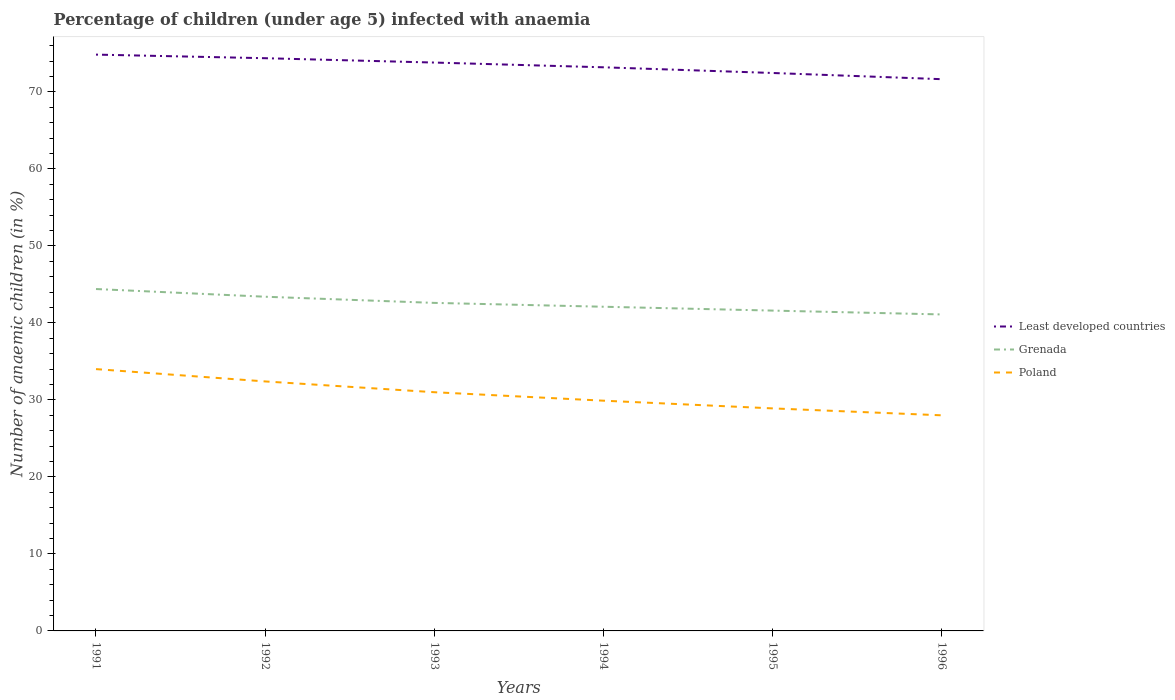Does the line corresponding to Grenada intersect with the line corresponding to Least developed countries?
Keep it short and to the point. No. Is the number of lines equal to the number of legend labels?
Provide a short and direct response. Yes. Across all years, what is the maximum percentage of children infected with anaemia in in Grenada?
Give a very brief answer. 41.1. What is the total percentage of children infected with anaemia in in Grenada in the graph?
Make the answer very short. 1. What is the difference between the highest and the second highest percentage of children infected with anaemia in in Least developed countries?
Provide a succinct answer. 3.19. How many years are there in the graph?
Provide a succinct answer. 6. What is the difference between two consecutive major ticks on the Y-axis?
Give a very brief answer. 10. Are the values on the major ticks of Y-axis written in scientific E-notation?
Give a very brief answer. No. Does the graph contain any zero values?
Offer a terse response. No. How many legend labels are there?
Your answer should be very brief. 3. How are the legend labels stacked?
Your answer should be very brief. Vertical. What is the title of the graph?
Provide a succinct answer. Percentage of children (under age 5) infected with anaemia. What is the label or title of the X-axis?
Your response must be concise. Years. What is the label or title of the Y-axis?
Provide a succinct answer. Number of anaemic children (in %). What is the Number of anaemic children (in %) of Least developed countries in 1991?
Provide a short and direct response. 74.84. What is the Number of anaemic children (in %) of Grenada in 1991?
Make the answer very short. 44.4. What is the Number of anaemic children (in %) in Poland in 1991?
Give a very brief answer. 34. What is the Number of anaemic children (in %) in Least developed countries in 1992?
Your answer should be very brief. 74.38. What is the Number of anaemic children (in %) in Grenada in 1992?
Give a very brief answer. 43.4. What is the Number of anaemic children (in %) of Poland in 1992?
Provide a short and direct response. 32.4. What is the Number of anaemic children (in %) in Least developed countries in 1993?
Your response must be concise. 73.81. What is the Number of anaemic children (in %) in Grenada in 1993?
Your answer should be very brief. 42.6. What is the Number of anaemic children (in %) in Poland in 1993?
Offer a terse response. 31. What is the Number of anaemic children (in %) in Least developed countries in 1994?
Offer a very short reply. 73.2. What is the Number of anaemic children (in %) in Grenada in 1994?
Offer a very short reply. 42.1. What is the Number of anaemic children (in %) of Poland in 1994?
Make the answer very short. 29.9. What is the Number of anaemic children (in %) of Least developed countries in 1995?
Offer a terse response. 72.46. What is the Number of anaemic children (in %) of Grenada in 1995?
Provide a short and direct response. 41.6. What is the Number of anaemic children (in %) in Poland in 1995?
Your response must be concise. 28.9. What is the Number of anaemic children (in %) of Least developed countries in 1996?
Offer a terse response. 71.65. What is the Number of anaemic children (in %) of Grenada in 1996?
Your answer should be very brief. 41.1. What is the Number of anaemic children (in %) in Poland in 1996?
Ensure brevity in your answer.  28. Across all years, what is the maximum Number of anaemic children (in %) of Least developed countries?
Offer a terse response. 74.84. Across all years, what is the maximum Number of anaemic children (in %) in Grenada?
Your answer should be compact. 44.4. Across all years, what is the maximum Number of anaemic children (in %) in Poland?
Provide a succinct answer. 34. Across all years, what is the minimum Number of anaemic children (in %) in Least developed countries?
Your response must be concise. 71.65. Across all years, what is the minimum Number of anaemic children (in %) of Grenada?
Your response must be concise. 41.1. What is the total Number of anaemic children (in %) in Least developed countries in the graph?
Provide a succinct answer. 440.33. What is the total Number of anaemic children (in %) in Grenada in the graph?
Keep it short and to the point. 255.2. What is the total Number of anaemic children (in %) of Poland in the graph?
Your response must be concise. 184.2. What is the difference between the Number of anaemic children (in %) of Least developed countries in 1991 and that in 1992?
Your response must be concise. 0.47. What is the difference between the Number of anaemic children (in %) in Poland in 1991 and that in 1992?
Provide a succinct answer. 1.6. What is the difference between the Number of anaemic children (in %) in Least developed countries in 1991 and that in 1993?
Your answer should be compact. 1.03. What is the difference between the Number of anaemic children (in %) in Grenada in 1991 and that in 1993?
Provide a short and direct response. 1.8. What is the difference between the Number of anaemic children (in %) in Poland in 1991 and that in 1993?
Provide a succinct answer. 3. What is the difference between the Number of anaemic children (in %) of Least developed countries in 1991 and that in 1994?
Make the answer very short. 1.65. What is the difference between the Number of anaemic children (in %) in Grenada in 1991 and that in 1994?
Offer a very short reply. 2.3. What is the difference between the Number of anaemic children (in %) in Poland in 1991 and that in 1994?
Give a very brief answer. 4.1. What is the difference between the Number of anaemic children (in %) of Least developed countries in 1991 and that in 1995?
Provide a short and direct response. 2.39. What is the difference between the Number of anaemic children (in %) of Grenada in 1991 and that in 1995?
Your response must be concise. 2.8. What is the difference between the Number of anaemic children (in %) in Least developed countries in 1991 and that in 1996?
Provide a succinct answer. 3.19. What is the difference between the Number of anaemic children (in %) of Grenada in 1991 and that in 1996?
Your answer should be very brief. 3.3. What is the difference between the Number of anaemic children (in %) of Least developed countries in 1992 and that in 1993?
Offer a very short reply. 0.56. What is the difference between the Number of anaemic children (in %) in Grenada in 1992 and that in 1993?
Offer a very short reply. 0.8. What is the difference between the Number of anaemic children (in %) in Least developed countries in 1992 and that in 1994?
Give a very brief answer. 1.18. What is the difference between the Number of anaemic children (in %) of Poland in 1992 and that in 1994?
Offer a terse response. 2.5. What is the difference between the Number of anaemic children (in %) in Least developed countries in 1992 and that in 1995?
Provide a short and direct response. 1.92. What is the difference between the Number of anaemic children (in %) of Grenada in 1992 and that in 1995?
Ensure brevity in your answer.  1.8. What is the difference between the Number of anaemic children (in %) in Least developed countries in 1992 and that in 1996?
Your answer should be very brief. 2.72. What is the difference between the Number of anaemic children (in %) of Least developed countries in 1993 and that in 1994?
Provide a succinct answer. 0.62. What is the difference between the Number of anaemic children (in %) in Poland in 1993 and that in 1994?
Provide a succinct answer. 1.1. What is the difference between the Number of anaemic children (in %) in Least developed countries in 1993 and that in 1995?
Make the answer very short. 1.35. What is the difference between the Number of anaemic children (in %) in Least developed countries in 1993 and that in 1996?
Your answer should be compact. 2.16. What is the difference between the Number of anaemic children (in %) in Poland in 1993 and that in 1996?
Your answer should be very brief. 3. What is the difference between the Number of anaemic children (in %) of Least developed countries in 1994 and that in 1995?
Ensure brevity in your answer.  0.74. What is the difference between the Number of anaemic children (in %) in Poland in 1994 and that in 1995?
Give a very brief answer. 1. What is the difference between the Number of anaemic children (in %) in Least developed countries in 1994 and that in 1996?
Give a very brief answer. 1.54. What is the difference between the Number of anaemic children (in %) of Grenada in 1994 and that in 1996?
Your response must be concise. 1. What is the difference between the Number of anaemic children (in %) of Poland in 1994 and that in 1996?
Provide a succinct answer. 1.9. What is the difference between the Number of anaemic children (in %) in Least developed countries in 1995 and that in 1996?
Your answer should be very brief. 0.81. What is the difference between the Number of anaemic children (in %) in Grenada in 1995 and that in 1996?
Provide a succinct answer. 0.5. What is the difference between the Number of anaemic children (in %) of Least developed countries in 1991 and the Number of anaemic children (in %) of Grenada in 1992?
Offer a terse response. 31.44. What is the difference between the Number of anaemic children (in %) in Least developed countries in 1991 and the Number of anaemic children (in %) in Poland in 1992?
Ensure brevity in your answer.  42.44. What is the difference between the Number of anaemic children (in %) in Least developed countries in 1991 and the Number of anaemic children (in %) in Grenada in 1993?
Offer a very short reply. 32.24. What is the difference between the Number of anaemic children (in %) of Least developed countries in 1991 and the Number of anaemic children (in %) of Poland in 1993?
Your answer should be compact. 43.84. What is the difference between the Number of anaemic children (in %) of Least developed countries in 1991 and the Number of anaemic children (in %) of Grenada in 1994?
Give a very brief answer. 32.74. What is the difference between the Number of anaemic children (in %) in Least developed countries in 1991 and the Number of anaemic children (in %) in Poland in 1994?
Make the answer very short. 44.94. What is the difference between the Number of anaemic children (in %) of Least developed countries in 1991 and the Number of anaemic children (in %) of Grenada in 1995?
Your response must be concise. 33.24. What is the difference between the Number of anaemic children (in %) of Least developed countries in 1991 and the Number of anaemic children (in %) of Poland in 1995?
Ensure brevity in your answer.  45.94. What is the difference between the Number of anaemic children (in %) of Least developed countries in 1991 and the Number of anaemic children (in %) of Grenada in 1996?
Keep it short and to the point. 33.74. What is the difference between the Number of anaemic children (in %) in Least developed countries in 1991 and the Number of anaemic children (in %) in Poland in 1996?
Your answer should be compact. 46.84. What is the difference between the Number of anaemic children (in %) of Least developed countries in 1992 and the Number of anaemic children (in %) of Grenada in 1993?
Give a very brief answer. 31.78. What is the difference between the Number of anaemic children (in %) in Least developed countries in 1992 and the Number of anaemic children (in %) in Poland in 1993?
Keep it short and to the point. 43.38. What is the difference between the Number of anaemic children (in %) of Least developed countries in 1992 and the Number of anaemic children (in %) of Grenada in 1994?
Provide a short and direct response. 32.28. What is the difference between the Number of anaemic children (in %) in Least developed countries in 1992 and the Number of anaemic children (in %) in Poland in 1994?
Ensure brevity in your answer.  44.48. What is the difference between the Number of anaemic children (in %) of Least developed countries in 1992 and the Number of anaemic children (in %) of Grenada in 1995?
Your response must be concise. 32.78. What is the difference between the Number of anaemic children (in %) of Least developed countries in 1992 and the Number of anaemic children (in %) of Poland in 1995?
Your response must be concise. 45.48. What is the difference between the Number of anaemic children (in %) of Grenada in 1992 and the Number of anaemic children (in %) of Poland in 1995?
Your response must be concise. 14.5. What is the difference between the Number of anaemic children (in %) of Least developed countries in 1992 and the Number of anaemic children (in %) of Grenada in 1996?
Provide a short and direct response. 33.28. What is the difference between the Number of anaemic children (in %) in Least developed countries in 1992 and the Number of anaemic children (in %) in Poland in 1996?
Your answer should be very brief. 46.38. What is the difference between the Number of anaemic children (in %) of Grenada in 1992 and the Number of anaemic children (in %) of Poland in 1996?
Make the answer very short. 15.4. What is the difference between the Number of anaemic children (in %) of Least developed countries in 1993 and the Number of anaemic children (in %) of Grenada in 1994?
Give a very brief answer. 31.71. What is the difference between the Number of anaemic children (in %) of Least developed countries in 1993 and the Number of anaemic children (in %) of Poland in 1994?
Make the answer very short. 43.91. What is the difference between the Number of anaemic children (in %) of Grenada in 1993 and the Number of anaemic children (in %) of Poland in 1994?
Provide a short and direct response. 12.7. What is the difference between the Number of anaemic children (in %) of Least developed countries in 1993 and the Number of anaemic children (in %) of Grenada in 1995?
Your answer should be very brief. 32.21. What is the difference between the Number of anaemic children (in %) in Least developed countries in 1993 and the Number of anaemic children (in %) in Poland in 1995?
Provide a succinct answer. 44.91. What is the difference between the Number of anaemic children (in %) in Least developed countries in 1993 and the Number of anaemic children (in %) in Grenada in 1996?
Offer a terse response. 32.71. What is the difference between the Number of anaemic children (in %) in Least developed countries in 1993 and the Number of anaemic children (in %) in Poland in 1996?
Your response must be concise. 45.81. What is the difference between the Number of anaemic children (in %) in Least developed countries in 1994 and the Number of anaemic children (in %) in Grenada in 1995?
Your response must be concise. 31.6. What is the difference between the Number of anaemic children (in %) of Least developed countries in 1994 and the Number of anaemic children (in %) of Poland in 1995?
Provide a short and direct response. 44.3. What is the difference between the Number of anaemic children (in %) of Least developed countries in 1994 and the Number of anaemic children (in %) of Grenada in 1996?
Your response must be concise. 32.1. What is the difference between the Number of anaemic children (in %) in Least developed countries in 1994 and the Number of anaemic children (in %) in Poland in 1996?
Give a very brief answer. 45.2. What is the difference between the Number of anaemic children (in %) of Least developed countries in 1995 and the Number of anaemic children (in %) of Grenada in 1996?
Your answer should be very brief. 31.36. What is the difference between the Number of anaemic children (in %) in Least developed countries in 1995 and the Number of anaemic children (in %) in Poland in 1996?
Provide a short and direct response. 44.46. What is the average Number of anaemic children (in %) of Least developed countries per year?
Provide a succinct answer. 73.39. What is the average Number of anaemic children (in %) in Grenada per year?
Ensure brevity in your answer.  42.53. What is the average Number of anaemic children (in %) of Poland per year?
Your answer should be very brief. 30.7. In the year 1991, what is the difference between the Number of anaemic children (in %) in Least developed countries and Number of anaemic children (in %) in Grenada?
Your answer should be compact. 30.44. In the year 1991, what is the difference between the Number of anaemic children (in %) of Least developed countries and Number of anaemic children (in %) of Poland?
Offer a terse response. 40.84. In the year 1991, what is the difference between the Number of anaemic children (in %) of Grenada and Number of anaemic children (in %) of Poland?
Ensure brevity in your answer.  10.4. In the year 1992, what is the difference between the Number of anaemic children (in %) in Least developed countries and Number of anaemic children (in %) in Grenada?
Provide a succinct answer. 30.98. In the year 1992, what is the difference between the Number of anaemic children (in %) in Least developed countries and Number of anaemic children (in %) in Poland?
Give a very brief answer. 41.98. In the year 1992, what is the difference between the Number of anaemic children (in %) of Grenada and Number of anaemic children (in %) of Poland?
Offer a very short reply. 11. In the year 1993, what is the difference between the Number of anaemic children (in %) in Least developed countries and Number of anaemic children (in %) in Grenada?
Ensure brevity in your answer.  31.21. In the year 1993, what is the difference between the Number of anaemic children (in %) of Least developed countries and Number of anaemic children (in %) of Poland?
Ensure brevity in your answer.  42.81. In the year 1993, what is the difference between the Number of anaemic children (in %) of Grenada and Number of anaemic children (in %) of Poland?
Make the answer very short. 11.6. In the year 1994, what is the difference between the Number of anaemic children (in %) of Least developed countries and Number of anaemic children (in %) of Grenada?
Your answer should be compact. 31.1. In the year 1994, what is the difference between the Number of anaemic children (in %) of Least developed countries and Number of anaemic children (in %) of Poland?
Keep it short and to the point. 43.3. In the year 1995, what is the difference between the Number of anaemic children (in %) of Least developed countries and Number of anaemic children (in %) of Grenada?
Your answer should be very brief. 30.86. In the year 1995, what is the difference between the Number of anaemic children (in %) in Least developed countries and Number of anaemic children (in %) in Poland?
Provide a short and direct response. 43.56. In the year 1996, what is the difference between the Number of anaemic children (in %) of Least developed countries and Number of anaemic children (in %) of Grenada?
Ensure brevity in your answer.  30.55. In the year 1996, what is the difference between the Number of anaemic children (in %) of Least developed countries and Number of anaemic children (in %) of Poland?
Your answer should be very brief. 43.65. In the year 1996, what is the difference between the Number of anaemic children (in %) in Grenada and Number of anaemic children (in %) in Poland?
Your answer should be very brief. 13.1. What is the ratio of the Number of anaemic children (in %) of Poland in 1991 to that in 1992?
Offer a very short reply. 1.05. What is the ratio of the Number of anaemic children (in %) of Grenada in 1991 to that in 1993?
Give a very brief answer. 1.04. What is the ratio of the Number of anaemic children (in %) in Poland in 1991 to that in 1993?
Your response must be concise. 1.1. What is the ratio of the Number of anaemic children (in %) of Least developed countries in 1991 to that in 1994?
Give a very brief answer. 1.02. What is the ratio of the Number of anaemic children (in %) of Grenada in 1991 to that in 1994?
Your answer should be very brief. 1.05. What is the ratio of the Number of anaemic children (in %) in Poland in 1991 to that in 1994?
Your response must be concise. 1.14. What is the ratio of the Number of anaemic children (in %) of Least developed countries in 1991 to that in 1995?
Keep it short and to the point. 1.03. What is the ratio of the Number of anaemic children (in %) in Grenada in 1991 to that in 1995?
Your answer should be compact. 1.07. What is the ratio of the Number of anaemic children (in %) in Poland in 1991 to that in 1995?
Your answer should be very brief. 1.18. What is the ratio of the Number of anaemic children (in %) in Least developed countries in 1991 to that in 1996?
Make the answer very short. 1.04. What is the ratio of the Number of anaemic children (in %) of Grenada in 1991 to that in 1996?
Provide a short and direct response. 1.08. What is the ratio of the Number of anaemic children (in %) in Poland in 1991 to that in 1996?
Your answer should be compact. 1.21. What is the ratio of the Number of anaemic children (in %) of Least developed countries in 1992 to that in 1993?
Ensure brevity in your answer.  1.01. What is the ratio of the Number of anaemic children (in %) in Grenada in 1992 to that in 1993?
Offer a terse response. 1.02. What is the ratio of the Number of anaemic children (in %) in Poland in 1992 to that in 1993?
Your answer should be compact. 1.05. What is the ratio of the Number of anaemic children (in %) of Least developed countries in 1992 to that in 1994?
Provide a short and direct response. 1.02. What is the ratio of the Number of anaemic children (in %) of Grenada in 1992 to that in 1994?
Your answer should be compact. 1.03. What is the ratio of the Number of anaemic children (in %) in Poland in 1992 to that in 1994?
Provide a succinct answer. 1.08. What is the ratio of the Number of anaemic children (in %) of Least developed countries in 1992 to that in 1995?
Offer a terse response. 1.03. What is the ratio of the Number of anaemic children (in %) in Grenada in 1992 to that in 1995?
Keep it short and to the point. 1.04. What is the ratio of the Number of anaemic children (in %) of Poland in 1992 to that in 1995?
Your answer should be very brief. 1.12. What is the ratio of the Number of anaemic children (in %) in Least developed countries in 1992 to that in 1996?
Your answer should be very brief. 1.04. What is the ratio of the Number of anaemic children (in %) of Grenada in 1992 to that in 1996?
Your answer should be very brief. 1.06. What is the ratio of the Number of anaemic children (in %) of Poland in 1992 to that in 1996?
Make the answer very short. 1.16. What is the ratio of the Number of anaemic children (in %) of Least developed countries in 1993 to that in 1994?
Provide a short and direct response. 1.01. What is the ratio of the Number of anaemic children (in %) of Grenada in 1993 to that in 1994?
Offer a terse response. 1.01. What is the ratio of the Number of anaemic children (in %) in Poland in 1993 to that in 1994?
Provide a short and direct response. 1.04. What is the ratio of the Number of anaemic children (in %) of Least developed countries in 1993 to that in 1995?
Provide a short and direct response. 1.02. What is the ratio of the Number of anaemic children (in %) of Poland in 1993 to that in 1995?
Give a very brief answer. 1.07. What is the ratio of the Number of anaemic children (in %) in Least developed countries in 1993 to that in 1996?
Your answer should be compact. 1.03. What is the ratio of the Number of anaemic children (in %) in Grenada in 1993 to that in 1996?
Keep it short and to the point. 1.04. What is the ratio of the Number of anaemic children (in %) in Poland in 1993 to that in 1996?
Your answer should be compact. 1.11. What is the ratio of the Number of anaemic children (in %) in Least developed countries in 1994 to that in 1995?
Provide a succinct answer. 1.01. What is the ratio of the Number of anaemic children (in %) in Grenada in 1994 to that in 1995?
Ensure brevity in your answer.  1.01. What is the ratio of the Number of anaemic children (in %) in Poland in 1994 to that in 1995?
Your answer should be compact. 1.03. What is the ratio of the Number of anaemic children (in %) of Least developed countries in 1994 to that in 1996?
Offer a very short reply. 1.02. What is the ratio of the Number of anaemic children (in %) of Grenada in 1994 to that in 1996?
Keep it short and to the point. 1.02. What is the ratio of the Number of anaemic children (in %) of Poland in 1994 to that in 1996?
Provide a succinct answer. 1.07. What is the ratio of the Number of anaemic children (in %) in Least developed countries in 1995 to that in 1996?
Give a very brief answer. 1.01. What is the ratio of the Number of anaemic children (in %) in Grenada in 1995 to that in 1996?
Keep it short and to the point. 1.01. What is the ratio of the Number of anaemic children (in %) of Poland in 1995 to that in 1996?
Your answer should be compact. 1.03. What is the difference between the highest and the second highest Number of anaemic children (in %) in Least developed countries?
Your answer should be very brief. 0.47. What is the difference between the highest and the second highest Number of anaemic children (in %) of Grenada?
Make the answer very short. 1. What is the difference between the highest and the second highest Number of anaemic children (in %) in Poland?
Ensure brevity in your answer.  1.6. What is the difference between the highest and the lowest Number of anaemic children (in %) in Least developed countries?
Offer a very short reply. 3.19. What is the difference between the highest and the lowest Number of anaemic children (in %) in Grenada?
Give a very brief answer. 3.3. What is the difference between the highest and the lowest Number of anaemic children (in %) in Poland?
Give a very brief answer. 6. 